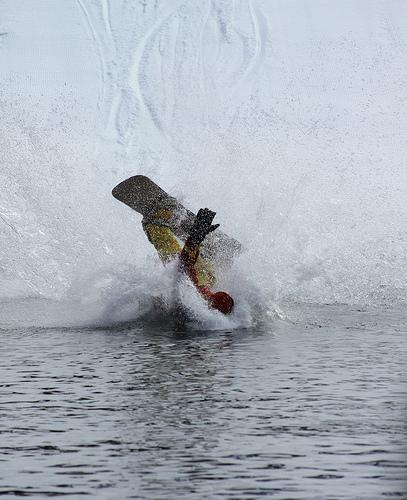Consider a situation where the snowboarder successfully lands on the water. What would be the likely outcome? The snowboarder would ride on the calm dark blue water, maintaining balance and possibly creating more splashes and ripples in the water. How many visible body parts are there of the person in the image? There are five visible body parts: head, arm, leg, feet, and hand. Determine the quality of the photograph in terms of colors, sharpness, and overall visual appeal. The image seems to have a variety of colors and objects, but the listed coordinates and dimensions are hard to visualize without the actual image. Analyze the interaction between the snowboarder and the water in the image. The snowboarder is falling into the water, causing a large, high splash and ripples around him, with water spraying all around. Describe the three most prominent objects in the image in a single sentence. A man wearing a red hat and yellow pants is falling off his dark yellow or brown snowboard into calm dark blue water, causing a large splash. Provide a short description of the main action happening in the image. A man on a snowboard wearing a red hat, yellow pants, and black gloves is falling into calm dark blue water, causing a large splash. What is the condition of the snow in the image? Snow appears to be covering an incline with visible board tracks, possibly due to the snowboarder's actions before falling into the water. Is there a difference between the two gloves the man is wearing? If so, what is it? Both gloves are black, but one is described as "black snow glove" and the other as "a black glove"; there may be a slight design difference. What are the main emotions associated with this image considering the scene and the snowboarder's situation? Amazement, thrill, and a touch of anxiety or concern as the man is falling into the water. Count and describe the different colors of the snowboarder's outfit in the image. There are 3 distinct colors: red (hat & sleeves), yellow (pants & boots), and black (gloves & snowboard). 